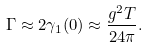Convert formula to latex. <formula><loc_0><loc_0><loc_500><loc_500>\Gamma \approx 2 \gamma _ { 1 } ( 0 ) \approx \frac { g ^ { 2 } T } { 2 4 \pi } .</formula> 